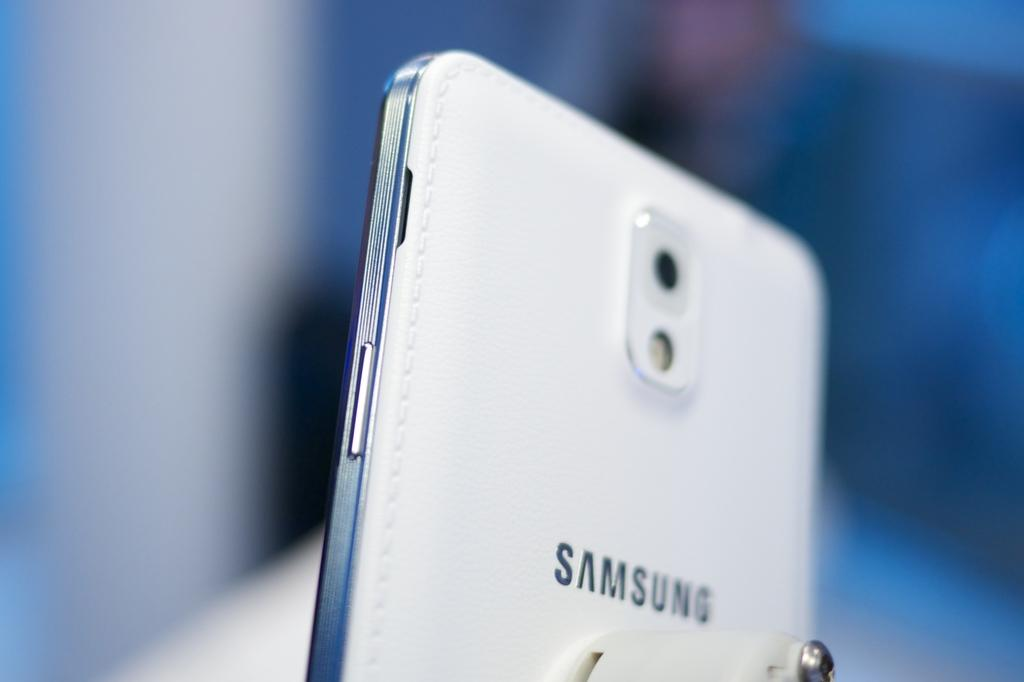<image>
Give a short and clear explanation of the subsequent image. White phone that has a word Samsung on the back. 